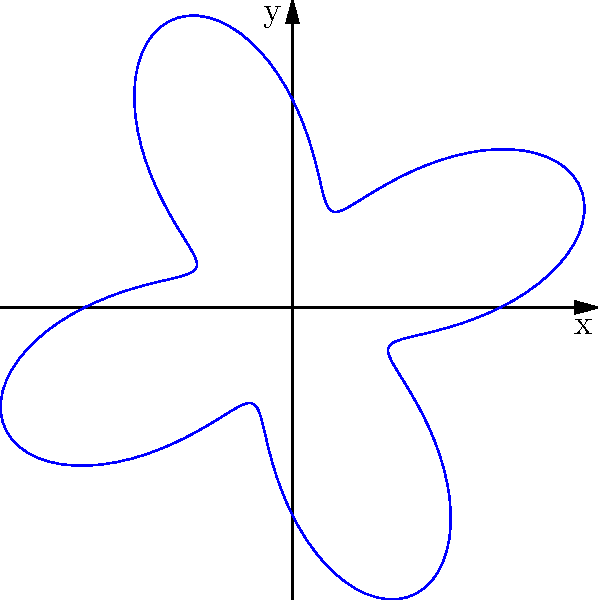As an indie singer-songwriter, you're experimenting with visualizing your music. You create a polar graph of a sound wave pattern from one of your songs. The equation of the pattern is $r = 1 + 0.5\sin(4\theta)$. How many "petals" or lobes does this pattern form? To determine the number of petals or lobes in this polar graph, we need to follow these steps:

1. Recognize that the general form of the equation is $r = a + b\sin(n\theta)$, where:
   $a = 1$ (the constant term)
   $b = 0.5$ (the amplitude of the sine wave)
   $n = 4$ (the frequency of the sine wave)

2. In polar graphs, the number of petals or lobes is determined by the frequency $n$ when it's an even number.

3. When $n$ is even, the number of petals is equal to $n$.

4. In this case, $n = 4$, which is an even number.

5. Therefore, the pattern will form 4 petals or lobes.

6. We can verify this by looking at the graph, which clearly shows 4 distinct lobes extending outward from the center.

This pattern creates a flower-like shape with 4 petals, which could represent the rhythmic or harmonic structure of your indie song in a visual format.
Answer: 4 petals 